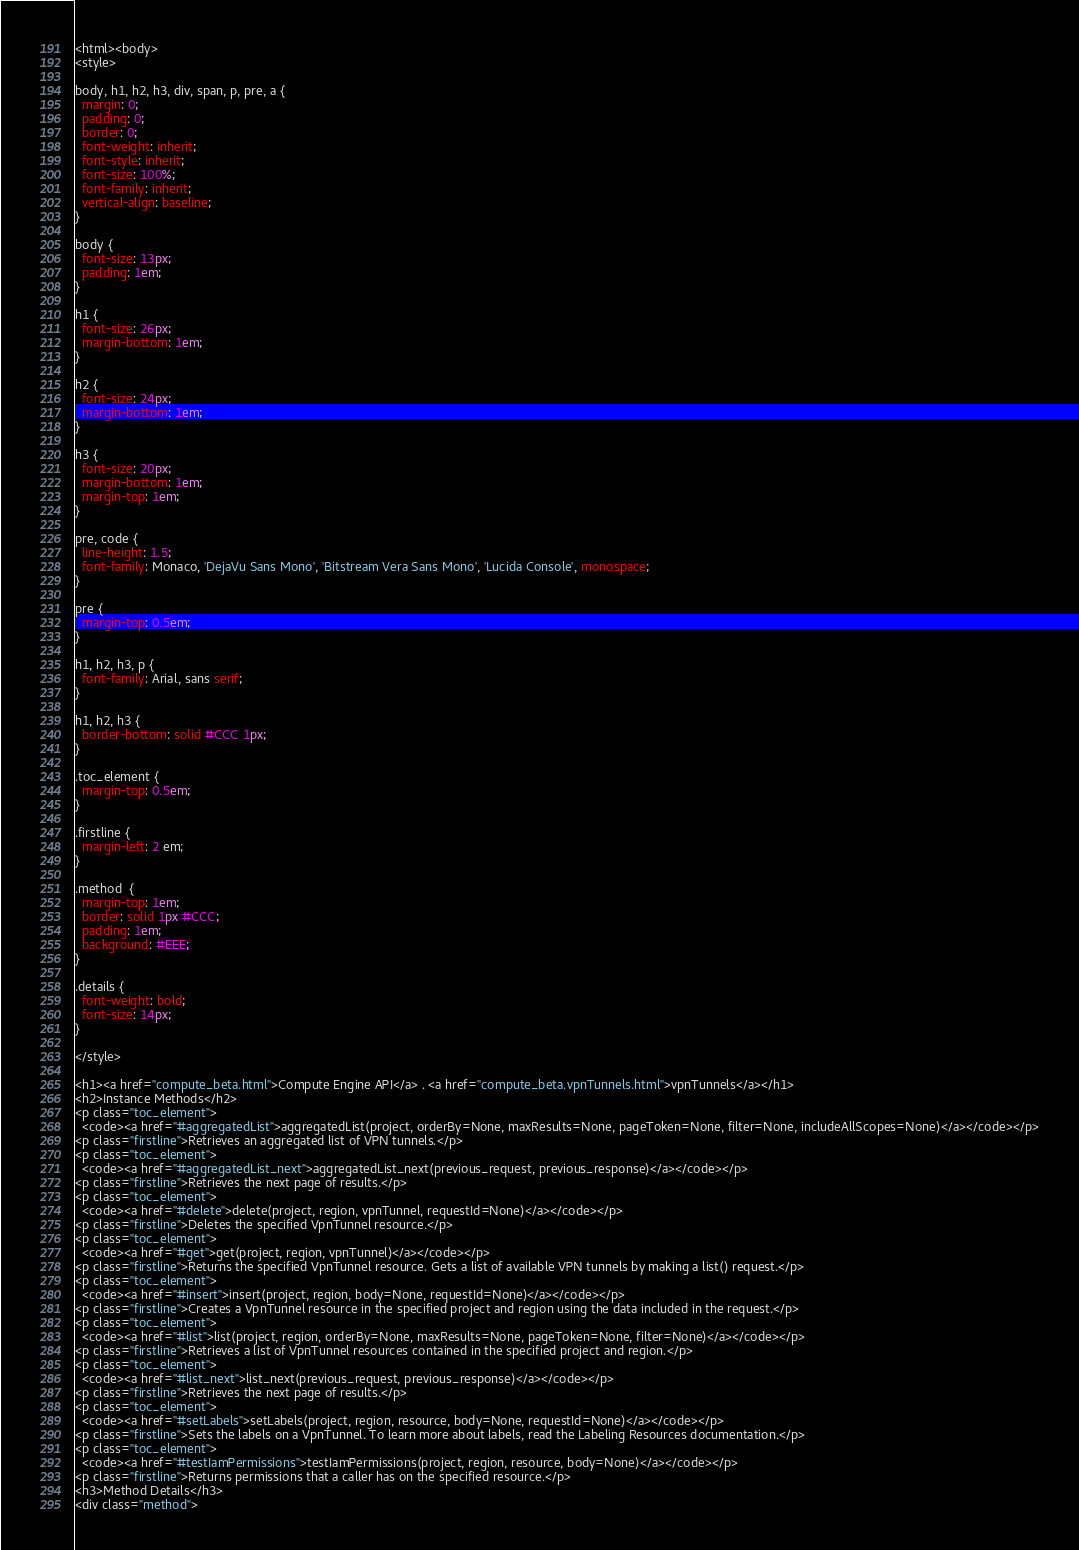Convert code to text. <code><loc_0><loc_0><loc_500><loc_500><_HTML_><html><body>
<style>

body, h1, h2, h3, div, span, p, pre, a {
  margin: 0;
  padding: 0;
  border: 0;
  font-weight: inherit;
  font-style: inherit;
  font-size: 100%;
  font-family: inherit;
  vertical-align: baseline;
}

body {
  font-size: 13px;
  padding: 1em;
}

h1 {
  font-size: 26px;
  margin-bottom: 1em;
}

h2 {
  font-size: 24px;
  margin-bottom: 1em;
}

h3 {
  font-size: 20px;
  margin-bottom: 1em;
  margin-top: 1em;
}

pre, code {
  line-height: 1.5;
  font-family: Monaco, 'DejaVu Sans Mono', 'Bitstream Vera Sans Mono', 'Lucida Console', monospace;
}

pre {
  margin-top: 0.5em;
}

h1, h2, h3, p {
  font-family: Arial, sans serif;
}

h1, h2, h3 {
  border-bottom: solid #CCC 1px;
}

.toc_element {
  margin-top: 0.5em;
}

.firstline {
  margin-left: 2 em;
}

.method  {
  margin-top: 1em;
  border: solid 1px #CCC;
  padding: 1em;
  background: #EEE;
}

.details {
  font-weight: bold;
  font-size: 14px;
}

</style>

<h1><a href="compute_beta.html">Compute Engine API</a> . <a href="compute_beta.vpnTunnels.html">vpnTunnels</a></h1>
<h2>Instance Methods</h2>
<p class="toc_element">
  <code><a href="#aggregatedList">aggregatedList(project, orderBy=None, maxResults=None, pageToken=None, filter=None, includeAllScopes=None)</a></code></p>
<p class="firstline">Retrieves an aggregated list of VPN tunnels.</p>
<p class="toc_element">
  <code><a href="#aggregatedList_next">aggregatedList_next(previous_request, previous_response)</a></code></p>
<p class="firstline">Retrieves the next page of results.</p>
<p class="toc_element">
  <code><a href="#delete">delete(project, region, vpnTunnel, requestId=None)</a></code></p>
<p class="firstline">Deletes the specified VpnTunnel resource.</p>
<p class="toc_element">
  <code><a href="#get">get(project, region, vpnTunnel)</a></code></p>
<p class="firstline">Returns the specified VpnTunnel resource. Gets a list of available VPN tunnels by making a list() request.</p>
<p class="toc_element">
  <code><a href="#insert">insert(project, region, body=None, requestId=None)</a></code></p>
<p class="firstline">Creates a VpnTunnel resource in the specified project and region using the data included in the request.</p>
<p class="toc_element">
  <code><a href="#list">list(project, region, orderBy=None, maxResults=None, pageToken=None, filter=None)</a></code></p>
<p class="firstline">Retrieves a list of VpnTunnel resources contained in the specified project and region.</p>
<p class="toc_element">
  <code><a href="#list_next">list_next(previous_request, previous_response)</a></code></p>
<p class="firstline">Retrieves the next page of results.</p>
<p class="toc_element">
  <code><a href="#setLabels">setLabels(project, region, resource, body=None, requestId=None)</a></code></p>
<p class="firstline">Sets the labels on a VpnTunnel. To learn more about labels, read the Labeling Resources documentation.</p>
<p class="toc_element">
  <code><a href="#testIamPermissions">testIamPermissions(project, region, resource, body=None)</a></code></p>
<p class="firstline">Returns permissions that a caller has on the specified resource.</p>
<h3>Method Details</h3>
<div class="method"></code> 